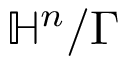<formula> <loc_0><loc_0><loc_500><loc_500>\mathbb { H } ^ { n } / \Gamma</formula> 